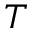Convert formula to latex. <formula><loc_0><loc_0><loc_500><loc_500>T</formula> 